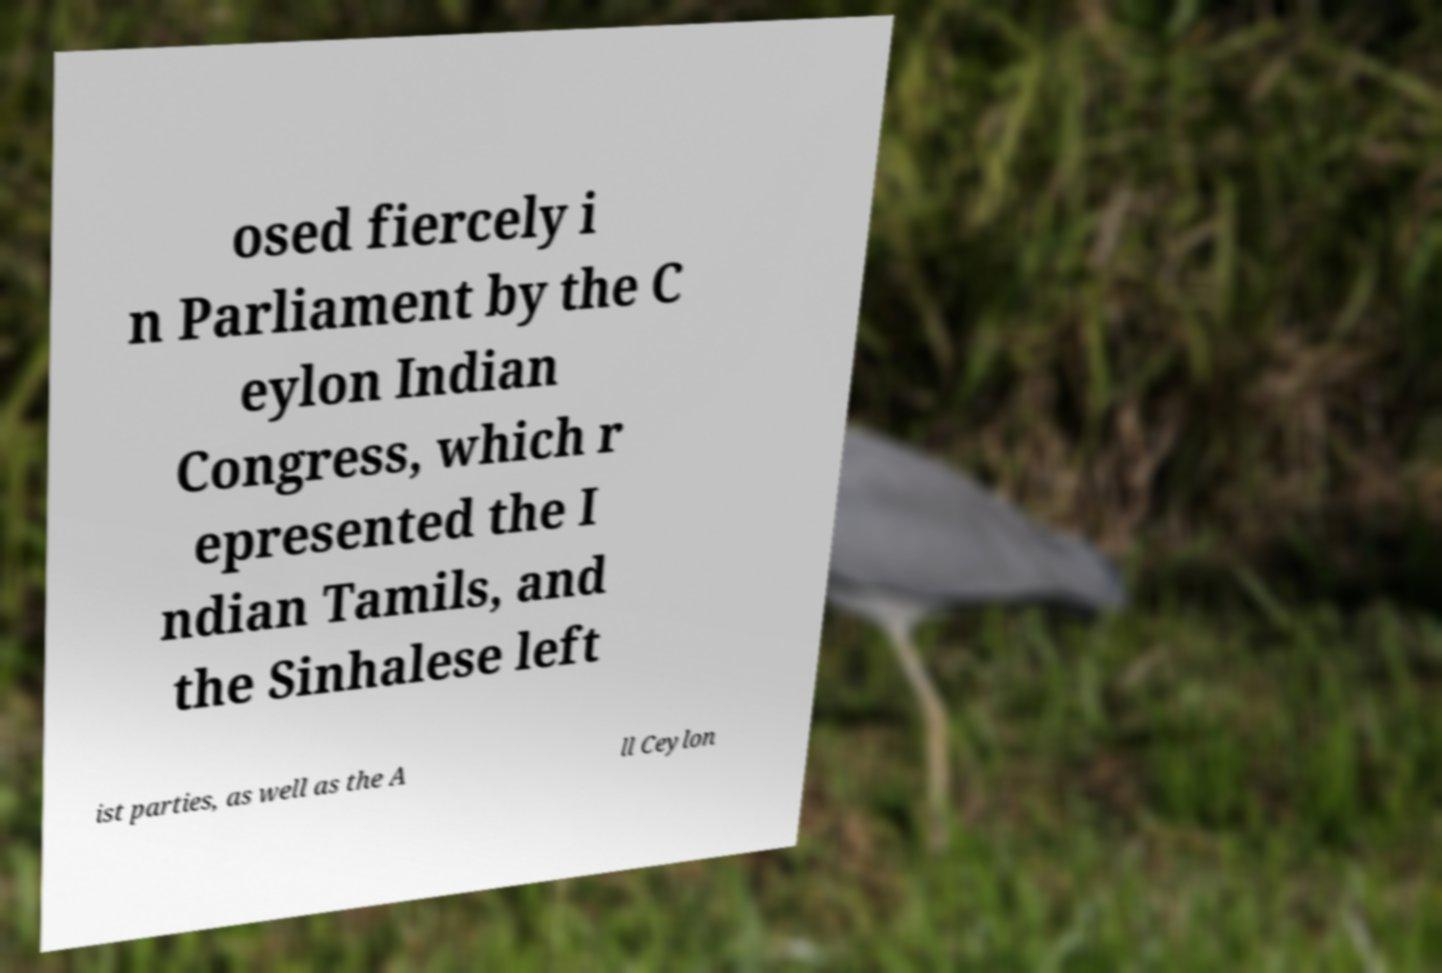Can you accurately transcribe the text from the provided image for me? osed fiercely i n Parliament by the C eylon Indian Congress, which r epresented the I ndian Tamils, and the Sinhalese left ist parties, as well as the A ll Ceylon 